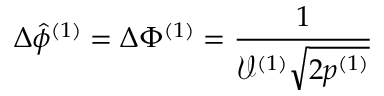Convert formula to latex. <formula><loc_0><loc_0><loc_500><loc_500>\Delta \hat { \phi } ^ { ( 1 ) } = \Delta \Phi ^ { ( 1 ) } = \frac { 1 } { \mathcal { V } ^ { ( 1 ) } \sqrt { 2 p ^ { ( 1 ) } } }</formula> 